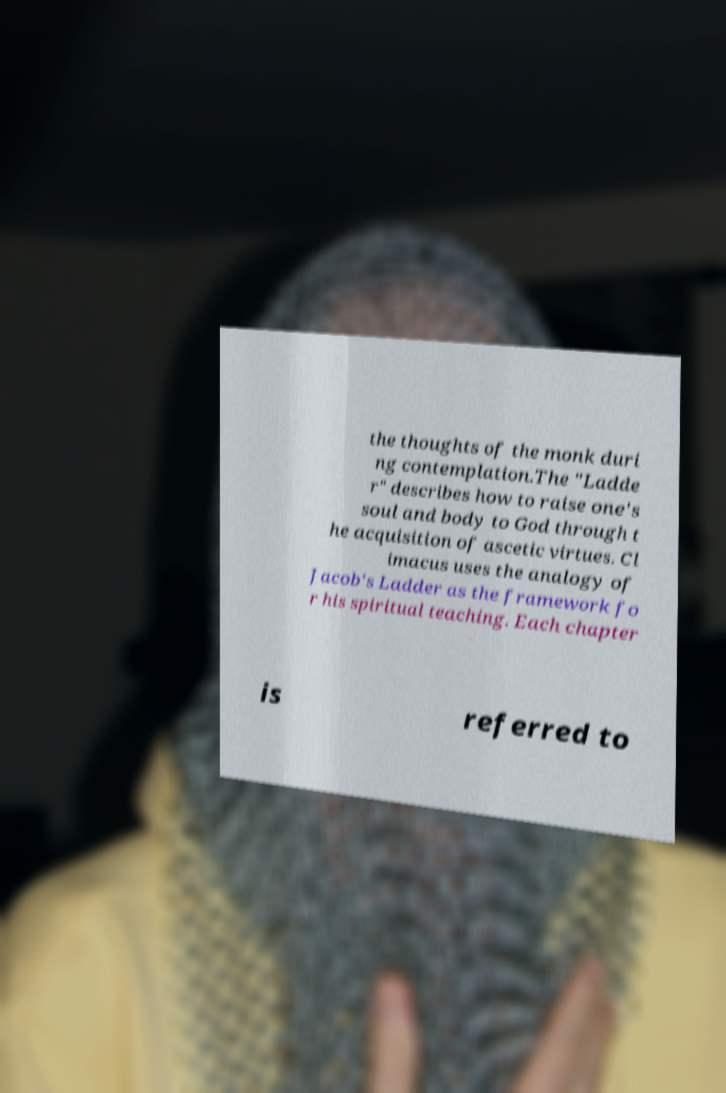What messages or text are displayed in this image? I need them in a readable, typed format. the thoughts of the monk duri ng contemplation.The "Ladde r" describes how to raise one's soul and body to God through t he acquisition of ascetic virtues. Cl imacus uses the analogy of Jacob's Ladder as the framework fo r his spiritual teaching. Each chapter is referred to 